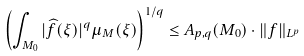<formula> <loc_0><loc_0><loc_500><loc_500>\left ( \int _ { M _ { 0 } } | \widehat { f } ( \xi ) | ^ { q } \mu _ { M } ( \xi ) \right ) ^ { 1 / q } \leq A _ { p , q } ( M _ { 0 } ) \cdot \| f \| _ { L ^ { p } }</formula> 